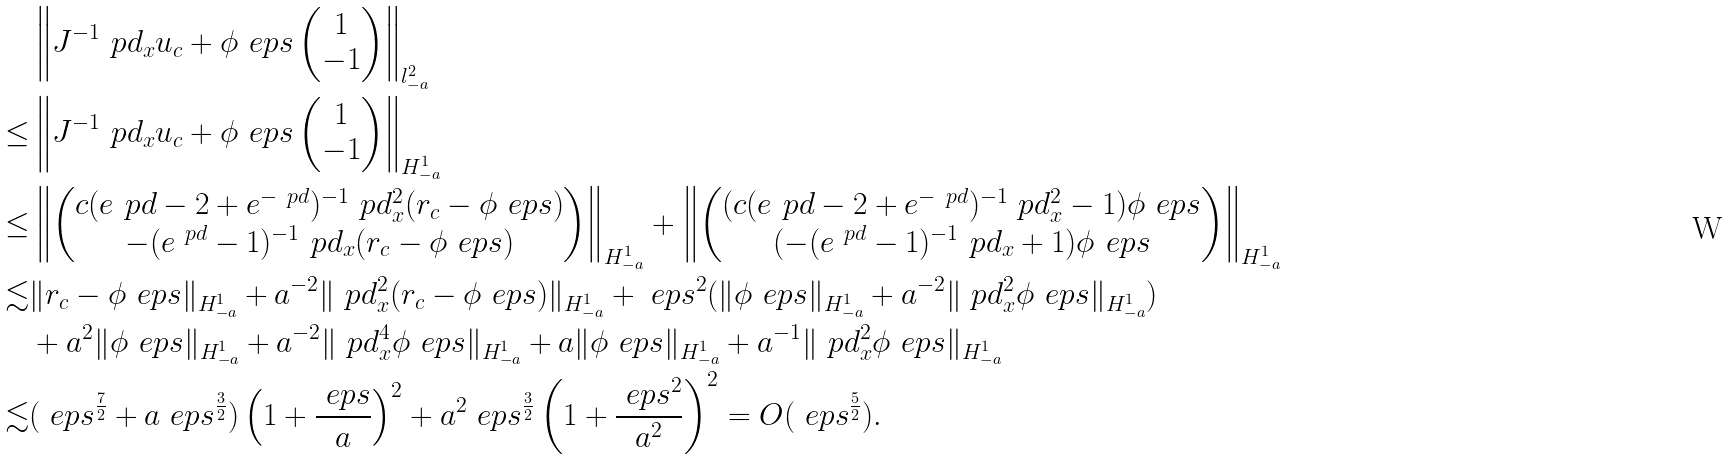Convert formula to latex. <formula><loc_0><loc_0><loc_500><loc_500>& \left \| J ^ { - 1 } \ p d _ { x } u _ { c } + \phi _ { \ } e p s \begin{pmatrix} 1 \\ - 1 \end{pmatrix} \right \| _ { l ^ { 2 } _ { - a } } \\ \leq & \left \| J ^ { - 1 } \ p d _ { x } u _ { c } + \phi _ { \ } e p s \begin{pmatrix} 1 \\ - 1 \end{pmatrix} \right \| _ { H ^ { 1 } _ { - a } } \\ \leq & \left \| \begin{pmatrix} c ( e ^ { \ } p d - 2 + e ^ { - \ p d } ) ^ { - 1 } \ p d _ { x } ^ { 2 } ( r _ { c } - \phi _ { \ } e p s ) \\ - ( e ^ { \ p d } - 1 ) ^ { - 1 } \ p d _ { x } ( r _ { c } - \phi _ { \ } e p s ) \end{pmatrix} \right \| _ { H ^ { 1 } _ { - a } } + \left \| \begin{pmatrix} ( c ( e ^ { \ } p d - 2 + e ^ { - \ p d } ) ^ { - 1 } \ p d _ { x } ^ { 2 } - 1 ) \phi _ { \ } e p s \\ ( - ( e ^ { \ p d } - 1 ) ^ { - 1 } \ p d _ { x } + 1 ) \phi _ { \ } e p s \end{pmatrix} \right \| _ { H ^ { 1 } _ { - a } } \\ \lesssim & \| r _ { c } - \phi _ { \ } e p s \| _ { H ^ { 1 } _ { - a } } + a ^ { - 2 } \| \ p d _ { x } ^ { 2 } ( r _ { c } - \phi _ { \ } e p s ) \| _ { H ^ { 1 } _ { - a } } + \ e p s ^ { 2 } ( \| \phi _ { \ } e p s \| _ { H ^ { 1 } _ { - a } } + a ^ { - 2 } \| \ p d _ { x } ^ { 2 } \phi _ { \ } e p s \| _ { H ^ { 1 } _ { - a } } ) \\ & + a ^ { 2 } \| \phi _ { \ } e p s \| _ { H ^ { 1 } _ { - a } } + a ^ { - 2 } \| \ p d _ { x } ^ { 4 } \phi _ { \ } e p s \| _ { H ^ { 1 } _ { - a } } + a \| \phi _ { \ } e p s \| _ { H ^ { 1 } _ { - a } } + a ^ { - 1 } \| \ p d _ { x } ^ { 2 } \phi _ { \ } e p s \| _ { H ^ { 1 } _ { - a } } \\ \lesssim & ( \ e p s ^ { \frac { 7 } { 2 } } + a \ e p s ^ { \frac { 3 } { 2 } } ) \left ( 1 + \frac { \ e p s } { a } \right ) ^ { 2 } + a ^ { 2 } \ e p s ^ { \frac { 3 } { 2 } } \left ( 1 + \frac { \ e p s ^ { 2 } } { a ^ { 2 } } \right ) ^ { 2 } = O ( \ e p s ^ { \frac { 5 } { 2 } } ) .</formula> 